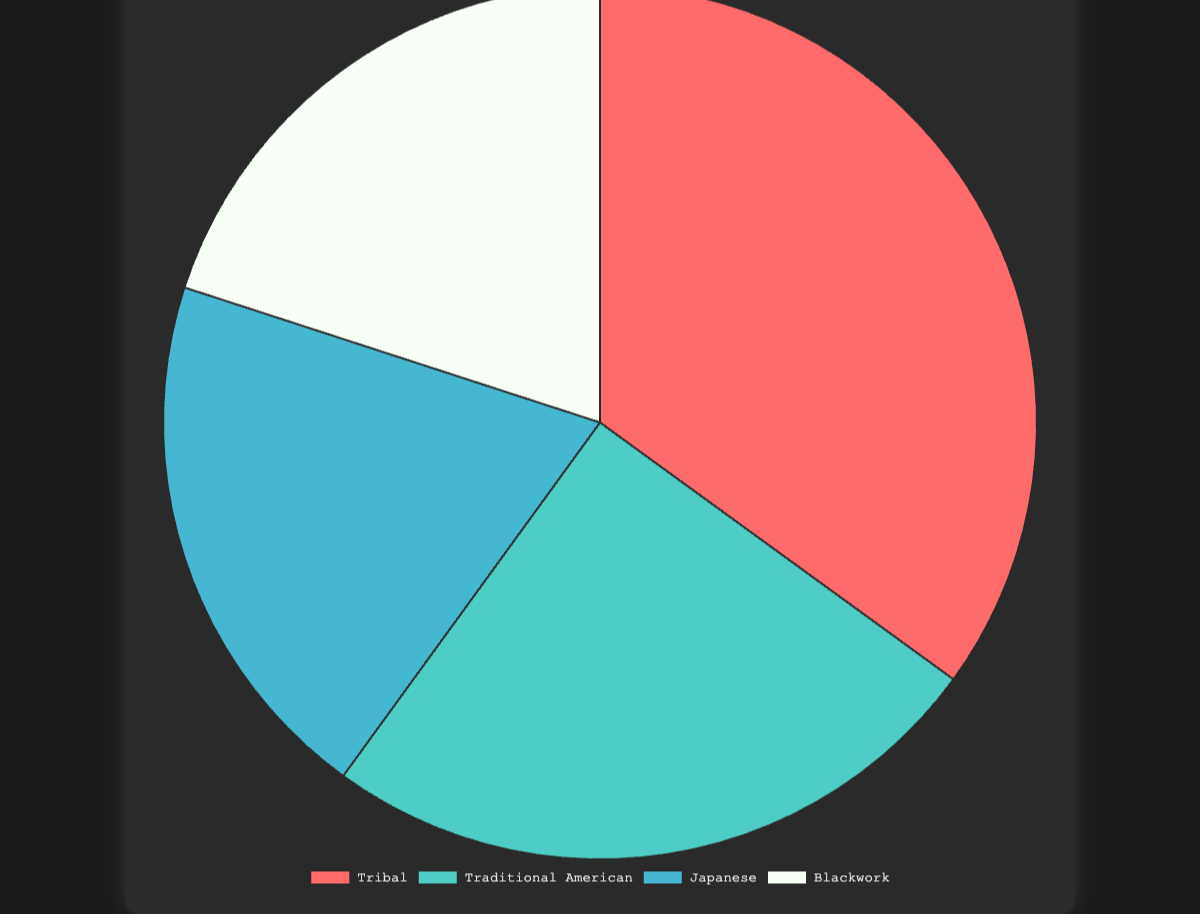What is the most prominent tattoo style in the 1990s? The largest section of the pie chart, with 35% of the total, corresponds to Tribal tattoos.
Answer: Tribal Which two tattoo styles share the same percentage? Both Japanese and Blackwork tattoo styles each have a 20% share in the pie chart.
Answer: Japanese and Blackwork What is the combined percentage of Traditional American and Japanese tattoo styles? Traditional American has 25% and Japanese has 20%. Summing these percentages gives 25% + 20% = 45%.
Answer: 45% How much higher is the percentage of Tribal tattoo styles compared to Blackwork? Tribal tattoos hold 35% of the total while Blackwork holds 20%. The difference is 35% - 20% = 15%.
Answer: 15% What tattoo style is represented by the red color in the chart? The pie chart section representing Tribal tattoos is colored red.
Answer: Tribal Which tattoo style occupies the smallest portion of the pie chart? Traditional American, Japanese, and Blackwork all share smaller sections, with 20% each, but among these, Tribal occupies a larger share of 35%. The smallest among all remaining styles is either Japanese and Blackwork 20%.
Answer: Japanese and Blackwork If you combine the percentages of Japanese and Blackwork tattoo styles, would they exceed the percentage of Tribal tattoo styles? Japanese and Blackwork each have 20%, combining them gives 20% + 20% = 40%, which exceeds the 35% for Tribal.
Answer: Yes How many percentage points more does Tribal hold compared to Traditional American tattoo styles? Tribal has 35% and Traditional American has 25%. The difference is 35% - 25% = 10%.
Answer: 10% Which tattoo style has the second highest percentage? With Traditional American holding 25%, it comes second to Tribal's 35% according to the pie chart.
Answer: Traditional American 